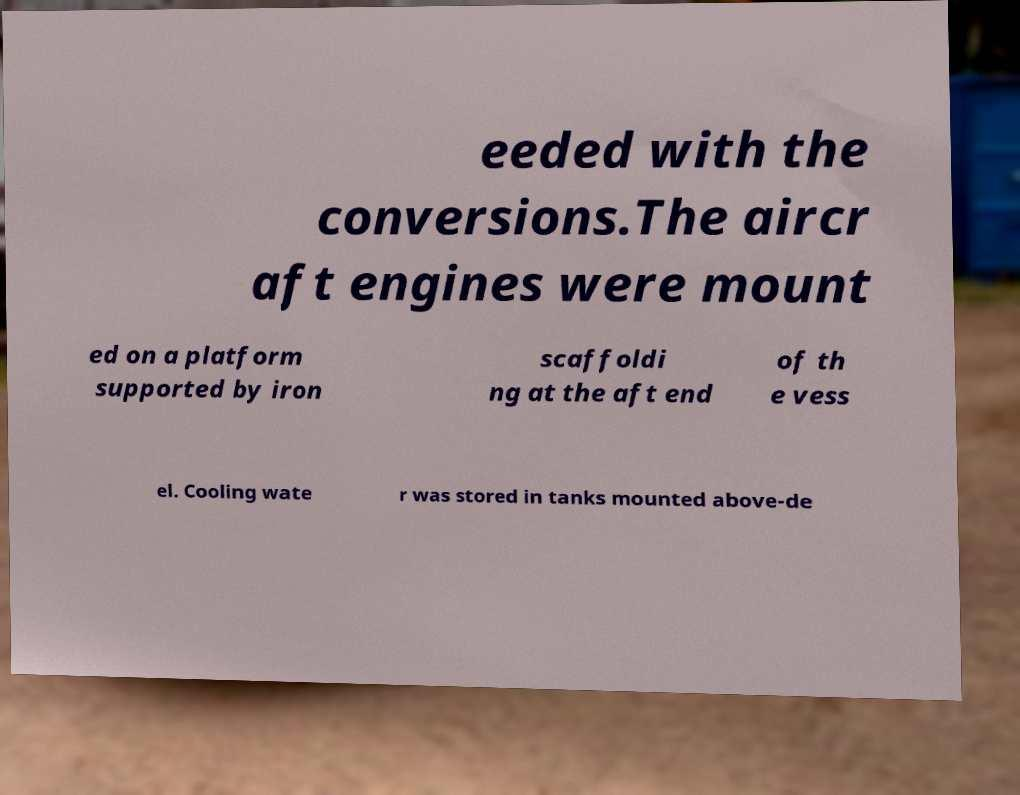Could you assist in decoding the text presented in this image and type it out clearly? eeded with the conversions.The aircr aft engines were mount ed on a platform supported by iron scaffoldi ng at the aft end of th e vess el. Cooling wate r was stored in tanks mounted above-de 